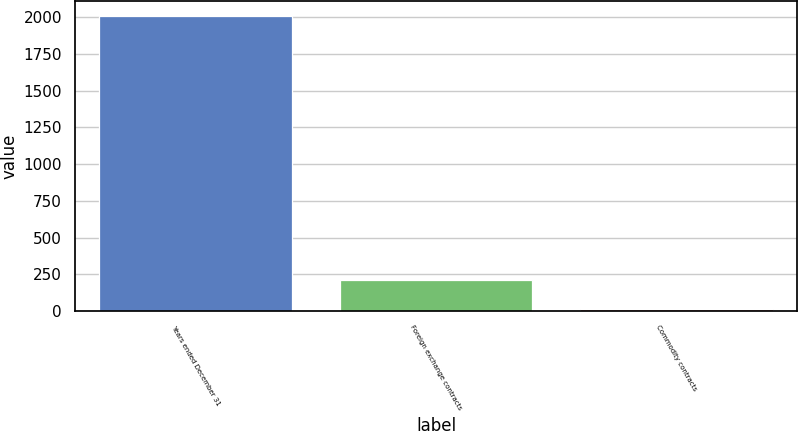<chart> <loc_0><loc_0><loc_500><loc_500><bar_chart><fcel>Years ended December 31<fcel>Foreign exchange contracts<fcel>Commodity contracts<nl><fcel>2012<fcel>210.2<fcel>10<nl></chart> 